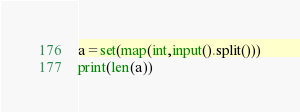<code> <loc_0><loc_0><loc_500><loc_500><_Python_>a=set(map(int,input().split()))
print(len(a))</code> 